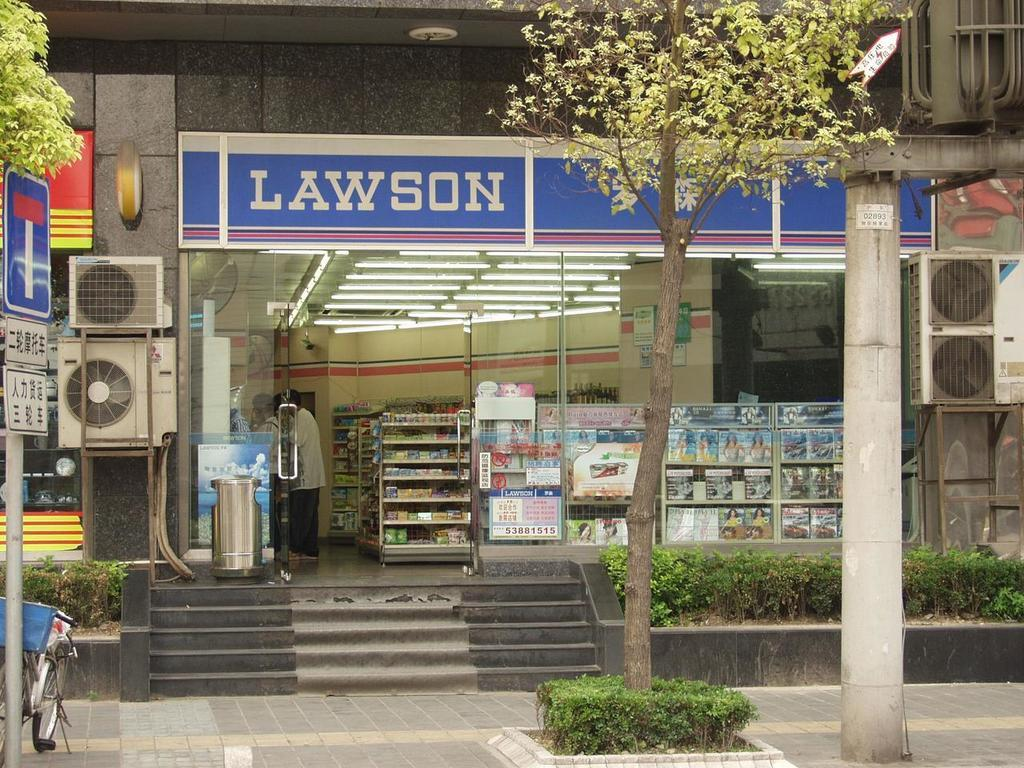<image>
Render a clear and concise summary of the photo. The small store shown has the name Lawson on its banner. 